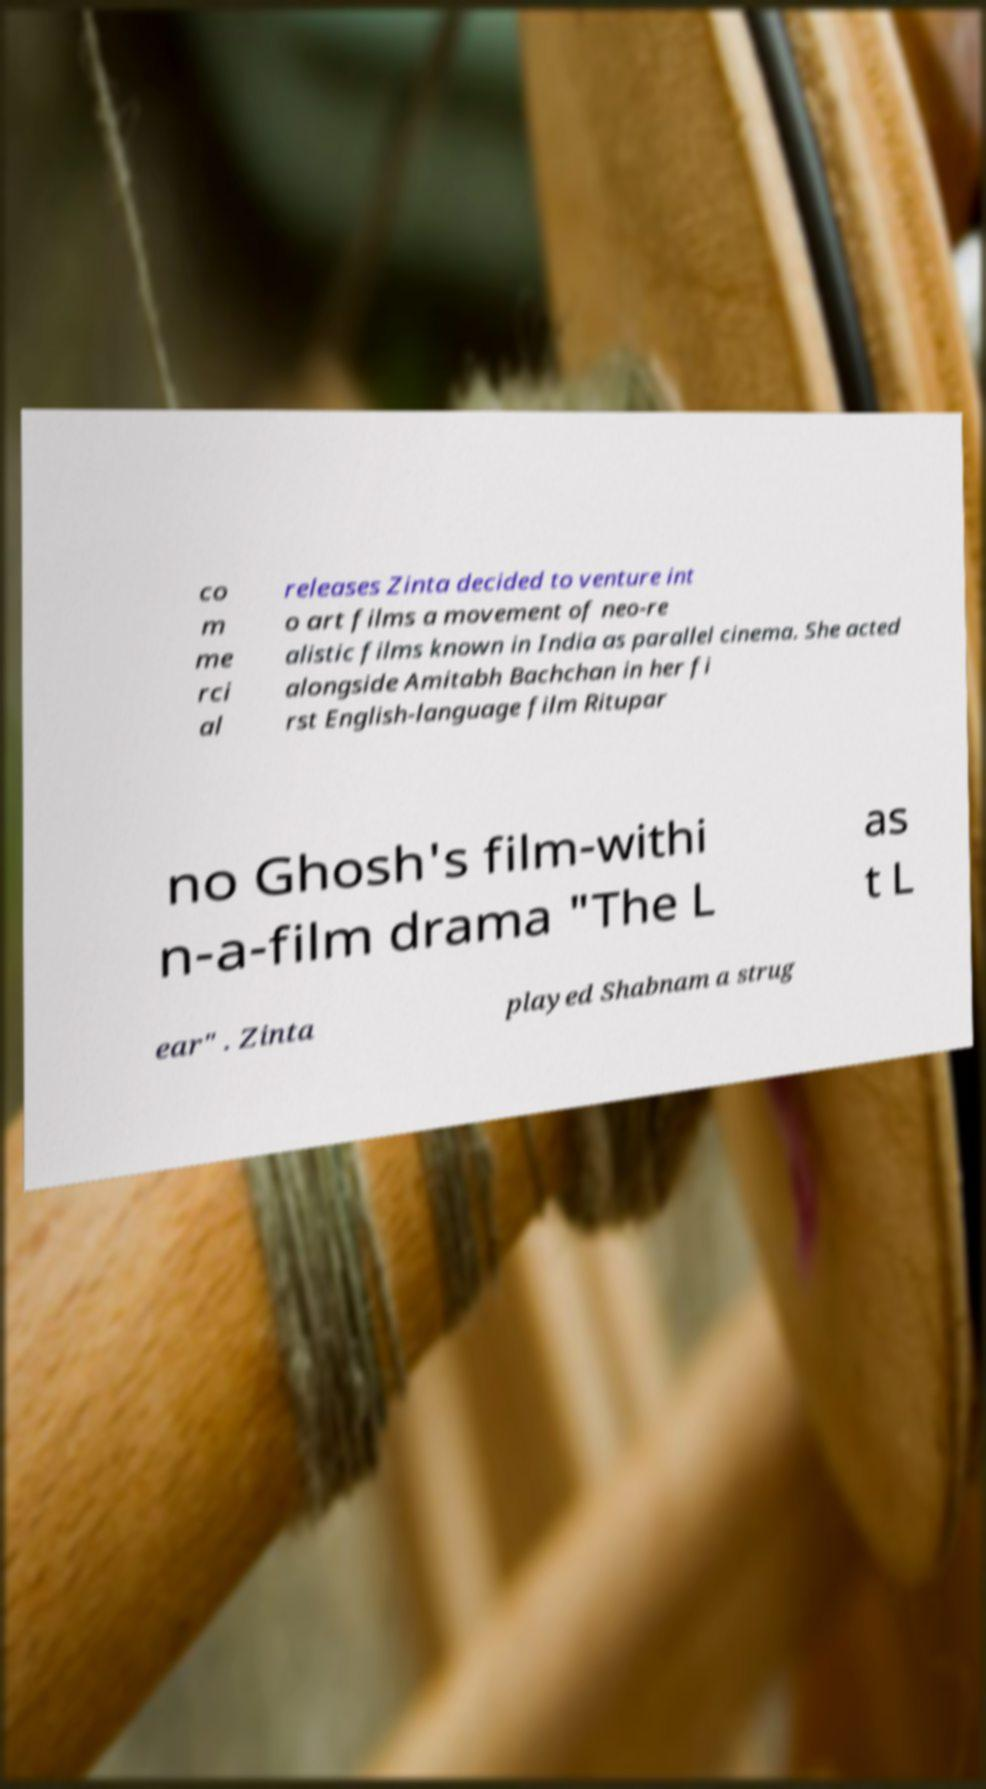Please read and relay the text visible in this image. What does it say? co m me rci al releases Zinta decided to venture int o art films a movement of neo-re alistic films known in India as parallel cinema. She acted alongside Amitabh Bachchan in her fi rst English-language film Ritupar no Ghosh's film-withi n-a-film drama "The L as t L ear" . Zinta played Shabnam a strug 